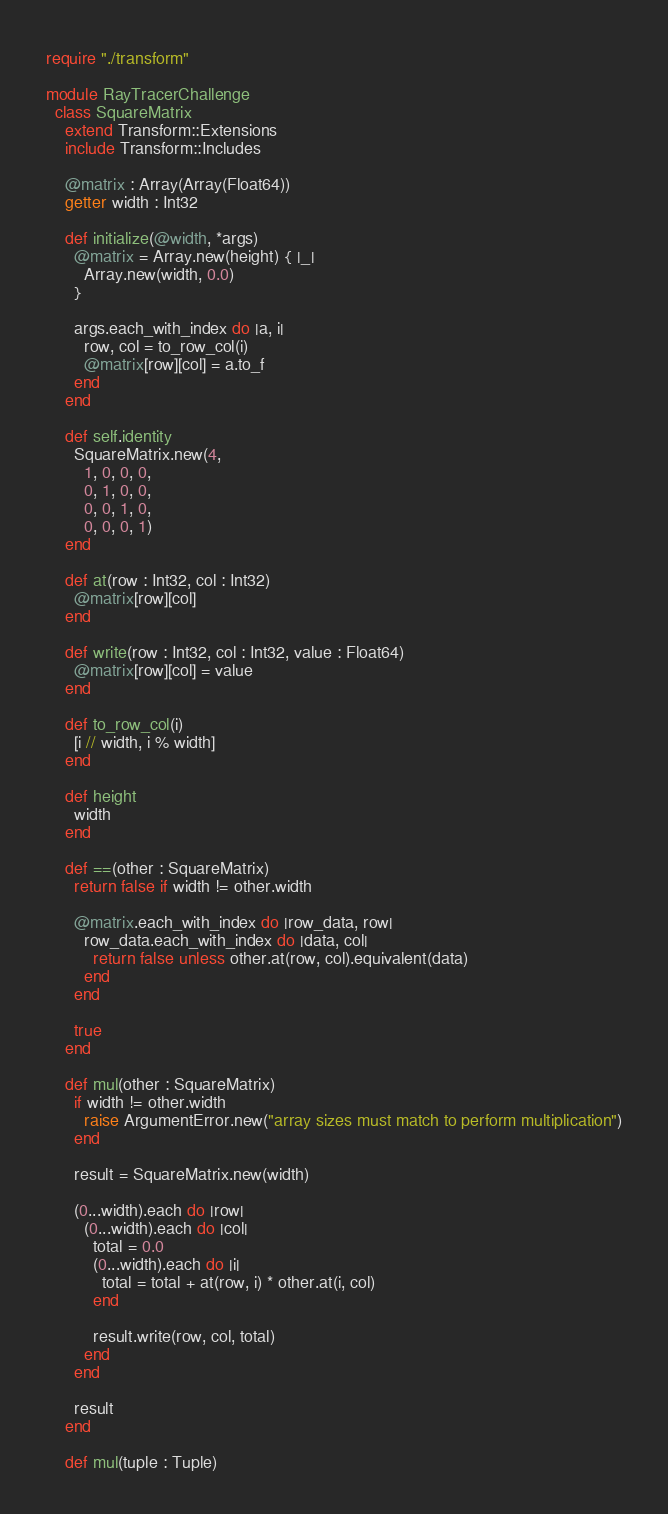Convert code to text. <code><loc_0><loc_0><loc_500><loc_500><_Crystal_>require "./transform"

module RayTracerChallenge
  class SquareMatrix
    extend Transform::Extensions
    include Transform::Includes

    @matrix : Array(Array(Float64))
    getter width : Int32

    def initialize(@width, *args)
      @matrix = Array.new(height) { |_|
        Array.new(width, 0.0)
      }

      args.each_with_index do |a, i|
        row, col = to_row_col(i)
        @matrix[row][col] = a.to_f
      end
    end

    def self.identity
      SquareMatrix.new(4,
        1, 0, 0, 0,
        0, 1, 0, 0,
        0, 0, 1, 0,
        0, 0, 0, 1)
    end

    def at(row : Int32, col : Int32)
      @matrix[row][col]
    end

    def write(row : Int32, col : Int32, value : Float64)
      @matrix[row][col] = value
    end

    def to_row_col(i)
      [i // width, i % width]
    end

    def height
      width
    end

    def ==(other : SquareMatrix)
      return false if width != other.width

      @matrix.each_with_index do |row_data, row|
        row_data.each_with_index do |data, col|
          return false unless other.at(row, col).equivalent(data)
        end
      end

      true
    end

    def mul(other : SquareMatrix)
      if width != other.width
        raise ArgumentError.new("array sizes must match to perform multiplication")
      end

      result = SquareMatrix.new(width)

      (0...width).each do |row|
        (0...width).each do |col|
          total = 0.0
          (0...width).each do |i|
            total = total + at(row, i) * other.at(i, col)
          end

          result.write(row, col, total)
        end
      end

      result
    end

    def mul(tuple : Tuple)</code> 